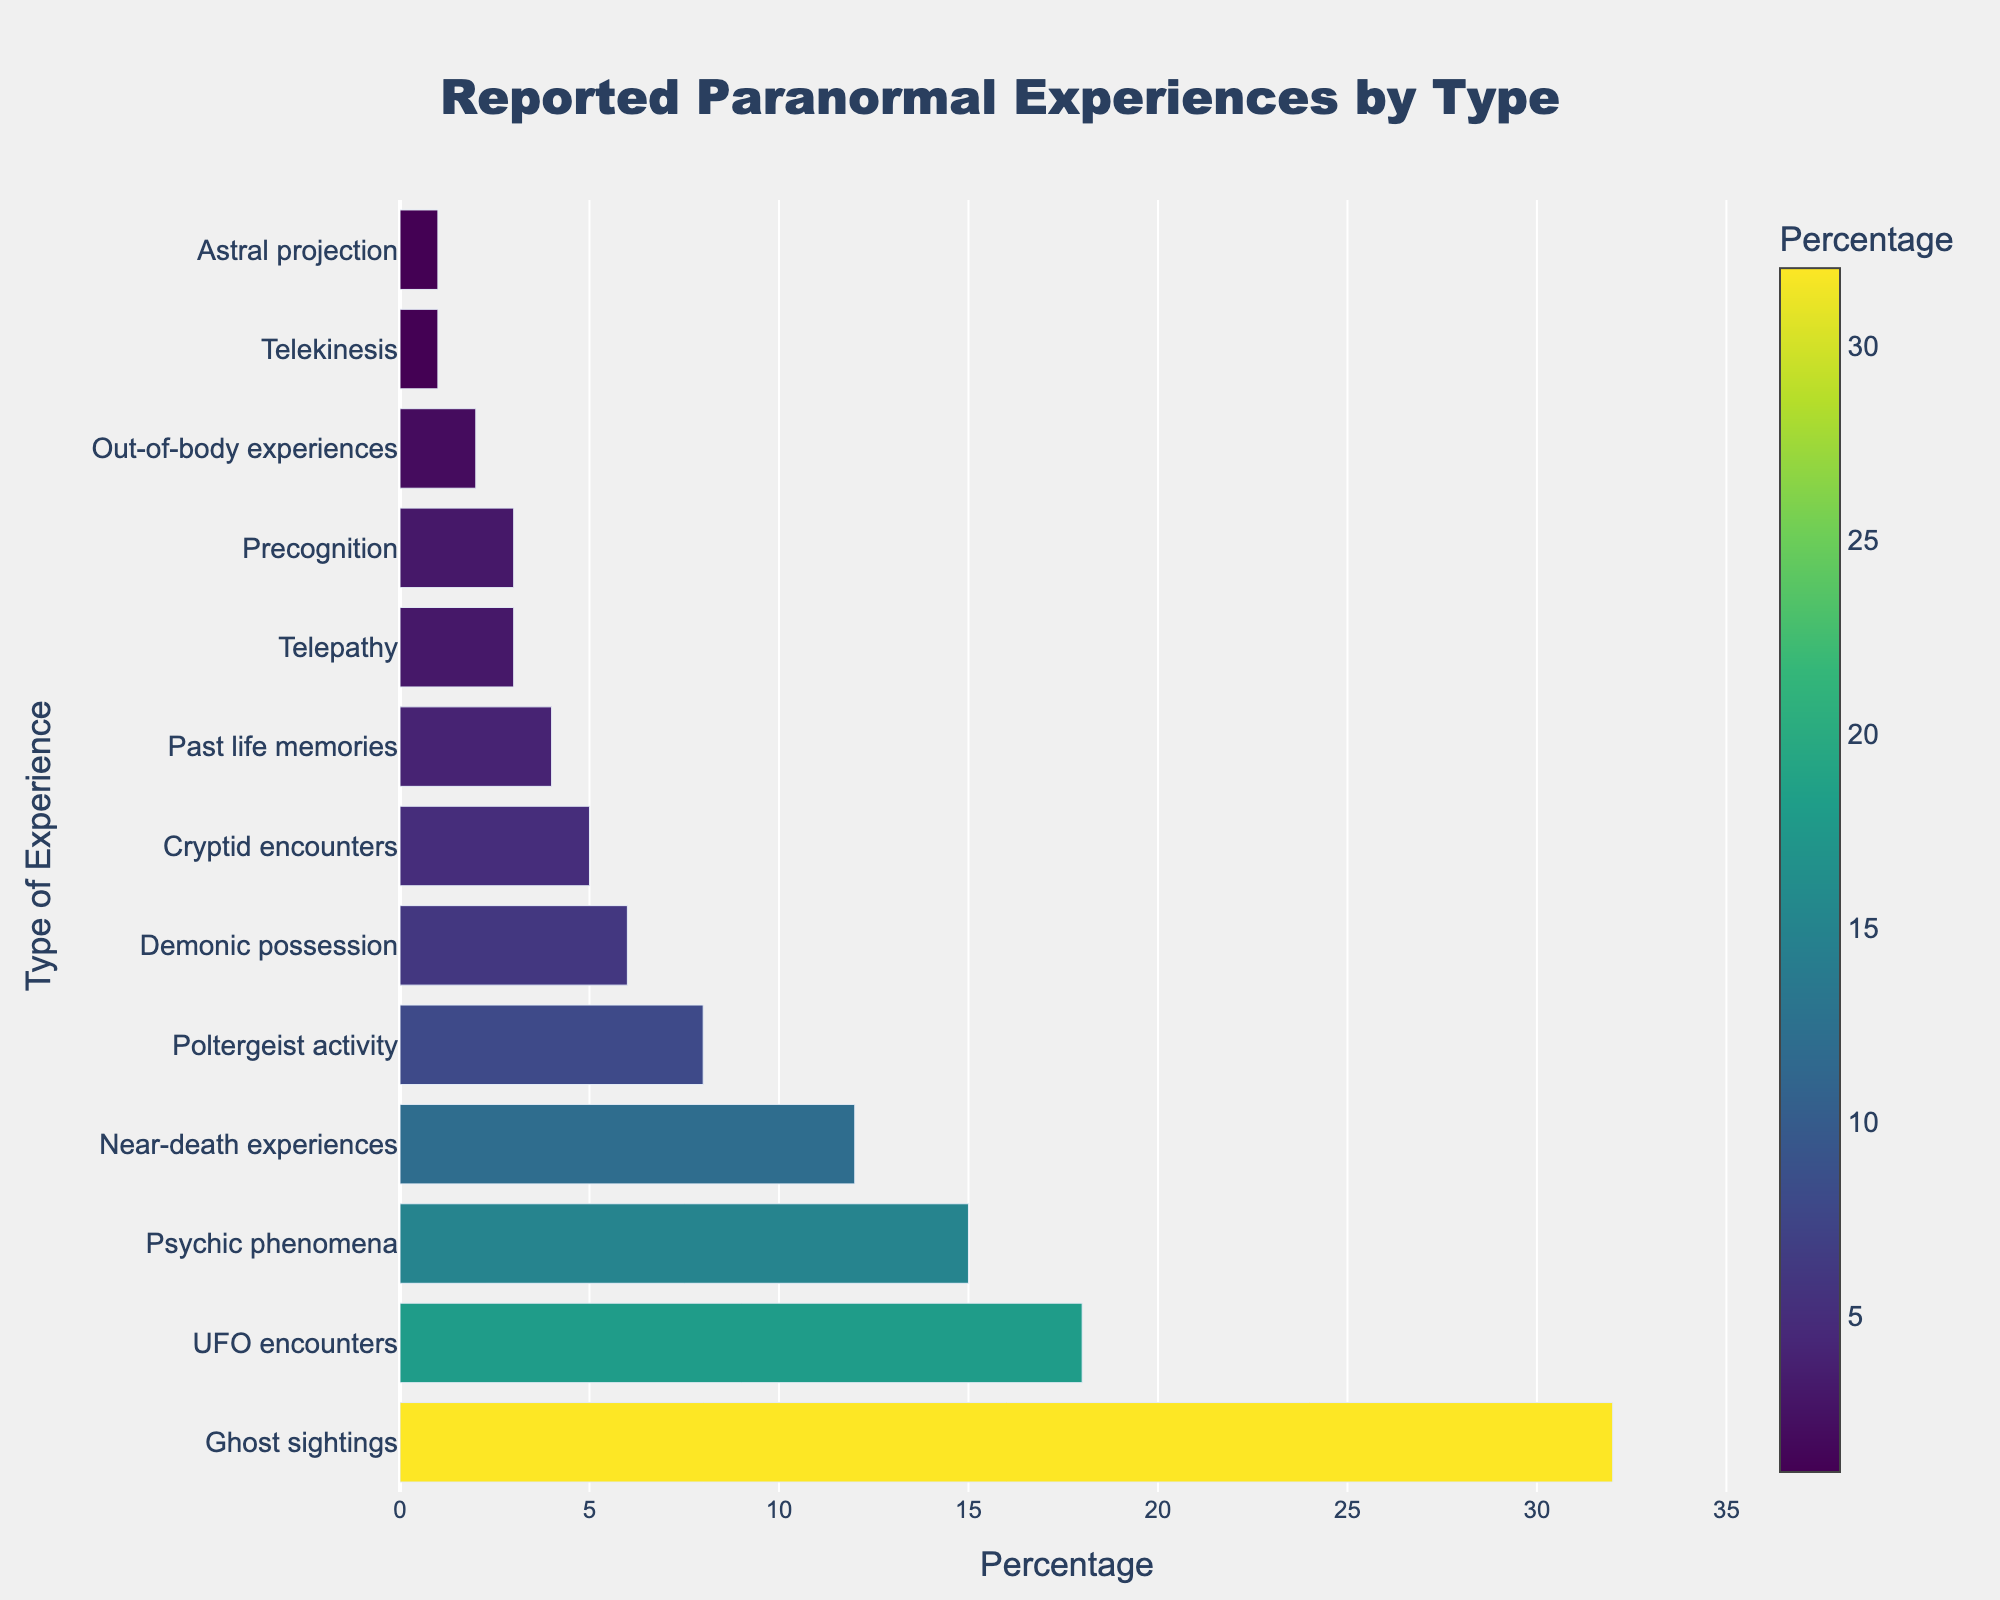What type of paranormal experience is reported the most? Look at the bar with the greatest length. The longest bar is for "Ghost sightings" at 32%.
Answer: Ghost sightings Which paranormal experience is reported the least? Check the shortest bar on the chart. The shortest bars are for "Telekinesis" and "Astral projection," each at 1%.
Answer: Telekinesis/Astral projection How much higher is the percentage for "Ghost sightings" compared to "UFO encounters"? "Ghost sightings" have a percentage of 32%, and "UFO encounters" have 18%. Subtract 18 from 32 to get the difference, 32 - 18 = 14%.
Answer: 14% What is the combined percentage for "Poltergeist activity" and "Demonic possession"? Add the percentages for "Poltergeist activity" (8%) and "Demonic possession" (6%). The sum is 8 + 6 = 14%.
Answer: 14% Are "Near-death experiences" reported more frequently than "Psychic phenomena"? Compare the bar lengths. "Near-death experiences" have a percentage of 12%, while "Psychic phenomena" have 15%. Since 12 is less than 15, "Near-death experiences" are reported less.
Answer: No What percentage of experiences other than "Ghost sightings" and "UFO encounters" combined? First, find the total percentage by summing all individual percentages (100%). Then subtract the combined percentage of "Ghost sightings" (32%) and "UFO encounters" (18%). That's 100 - (32 + 18) = 50%.
Answer: 50% What is the average percentage of "Cryptid encounters," "Past life memories," and "Telepathy"? Add the percentages for "Cryptid encounters" (5%), "Past life memories" (4%), and "Telepathy" (3%). Then divide by 3. The total sum is 5 + 4 + 3 = 12. Divide by 3, 12/3 = 4%.
Answer: 4% Which experiences are reported more frequently than "Demonic possession"? Look at the bars where the percentage is greater than 6% ("Ghost sightings" – 32%, "UFO encounters" – 18%, "Psychic phenomena" – 15%, "Near-death experiences" – 12%, "Poltergeist activity" – 8%).
Answer: Ghost sightings, UFO encounters, Psychic phenomena, Near-death experiences, Poltergeist activity If you combine "Precognition" and "Out-of-body experiences," does the total equal "Poltergeist activity"? Add the percentages for "Precognition" (3%) and "Out-of-body experiences" (2%). The sum is 3 + 2 = 5%. Compare this with "Poltergeist activity" (8%). Since 5 is less than 8, the total does not equal "Poltergeist activity."
Answer: No 